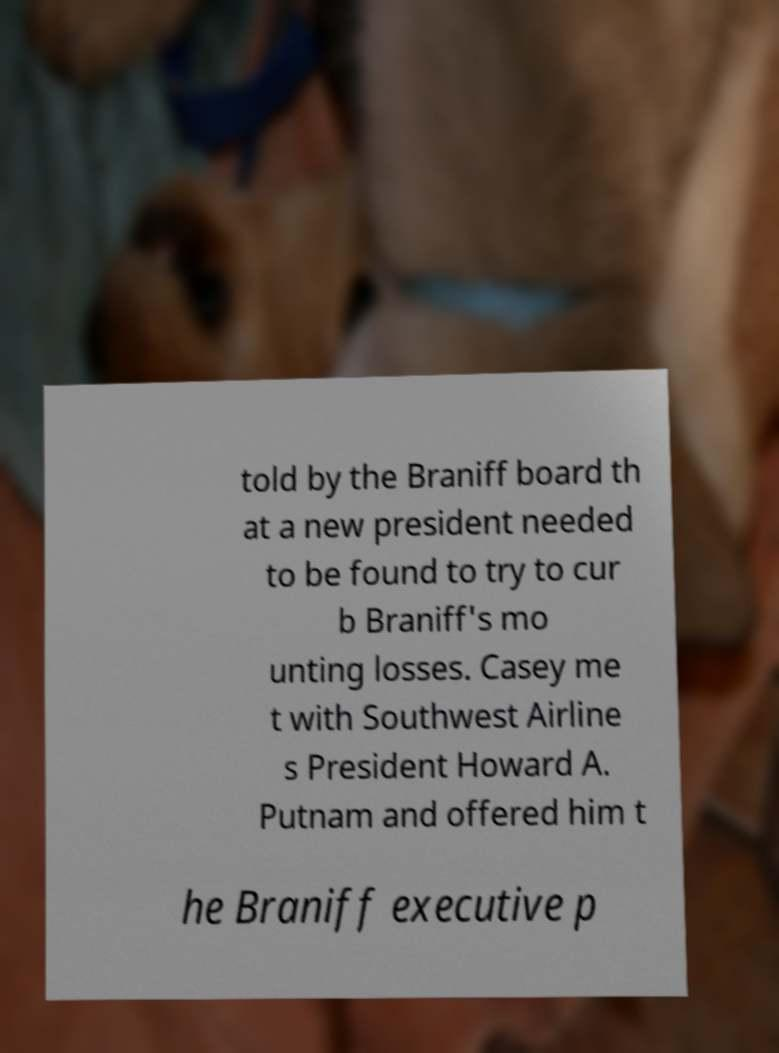What messages or text are displayed in this image? I need them in a readable, typed format. told by the Braniff board th at a new president needed to be found to try to cur b Braniff's mo unting losses. Casey me t with Southwest Airline s President Howard A. Putnam and offered him t he Braniff executive p 